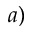<formula> <loc_0><loc_0><loc_500><loc_500>^ { a ) }</formula> 